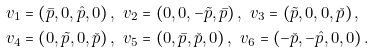Convert formula to latex. <formula><loc_0><loc_0><loc_500><loc_500>& v _ { 1 } = \left ( \bar { p } , 0 , \hat { p } , 0 \right ) , \ v _ { 2 } = \left ( 0 , 0 , - \tilde { p } , \bar { p } \right ) , \ v _ { 3 } = \left ( \tilde { p } , 0 , 0 , \check { p } \right ) , \\ & v _ { 4 } = \left ( 0 , \tilde { p } , 0 , \check { p } \right ) , \ v _ { 5 } = \left ( 0 , \bar { p } , \check { p } , 0 \right ) , \ v _ { 6 } = \left ( - \check { p } , - \hat { p } , 0 , 0 \right ) .</formula> 